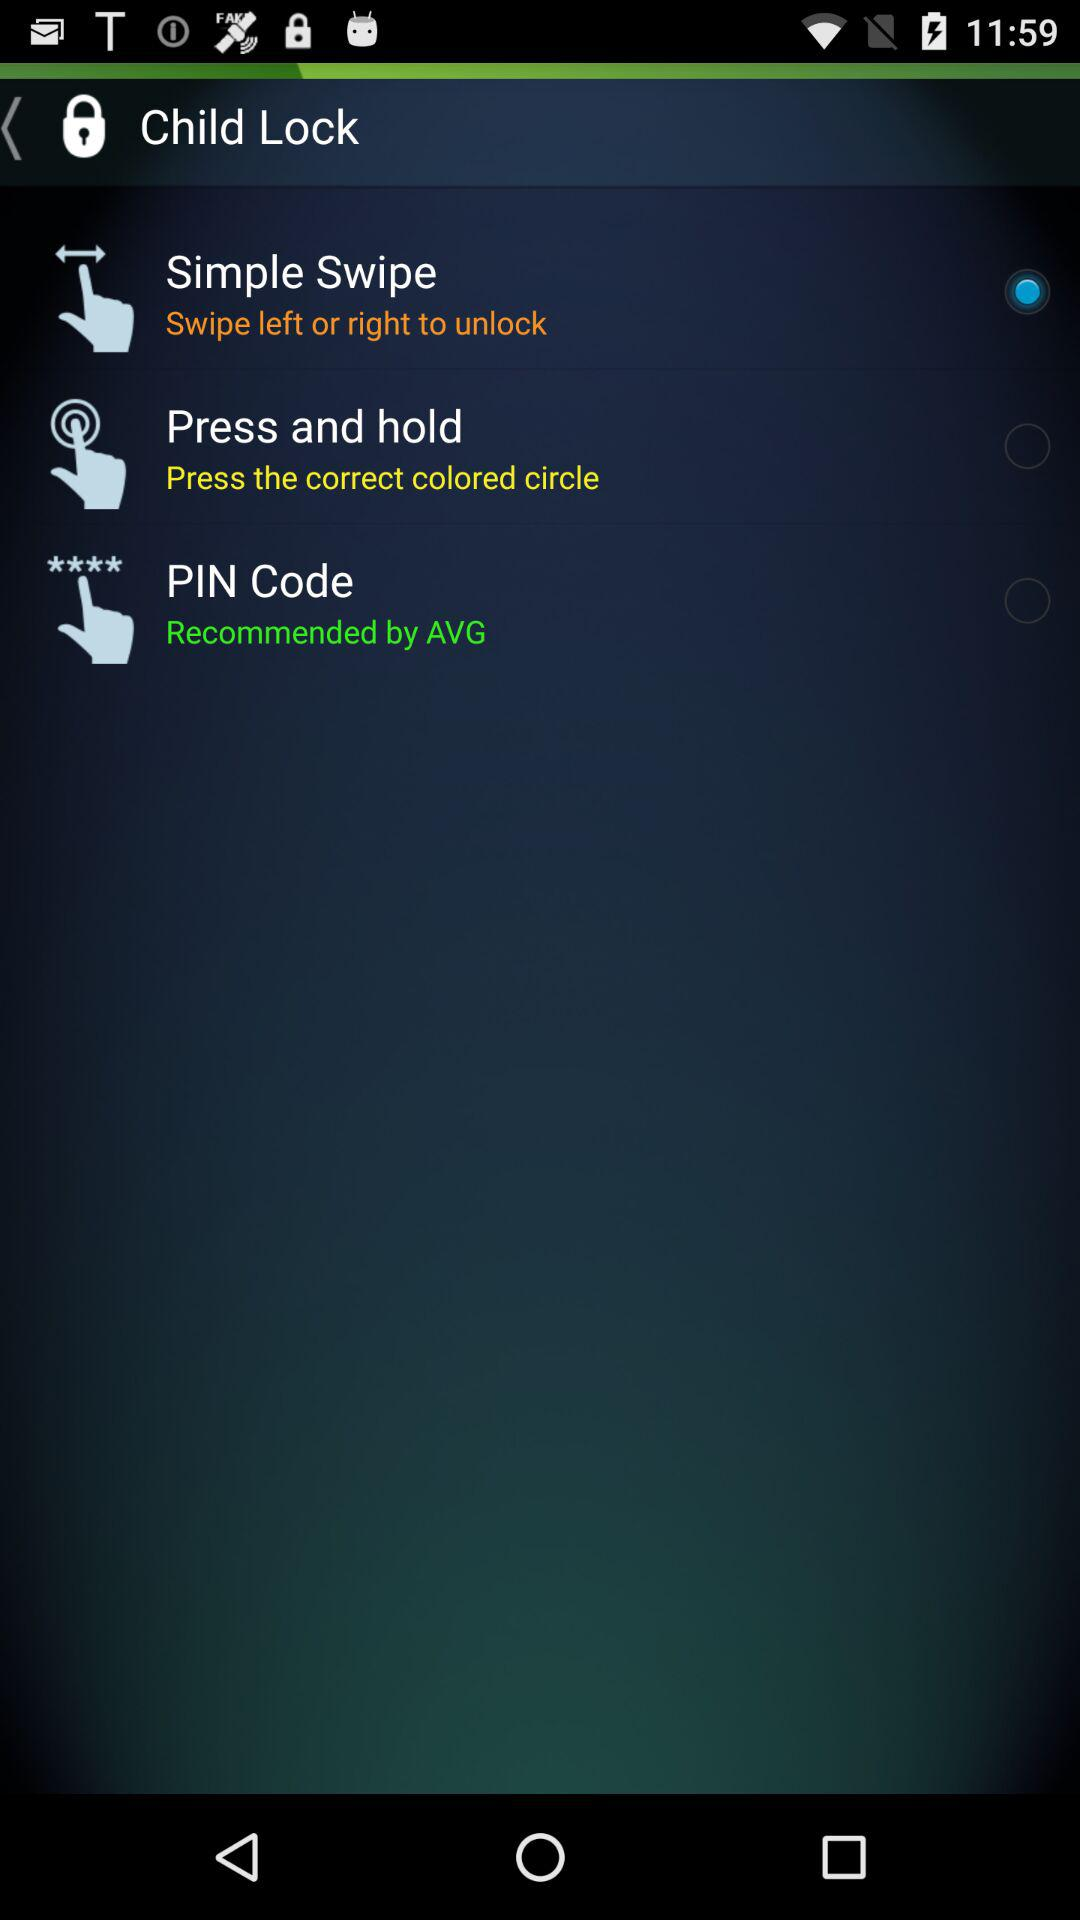Which child lock settings are not selected? The settings are "Press and hold" and "PIN Code". 